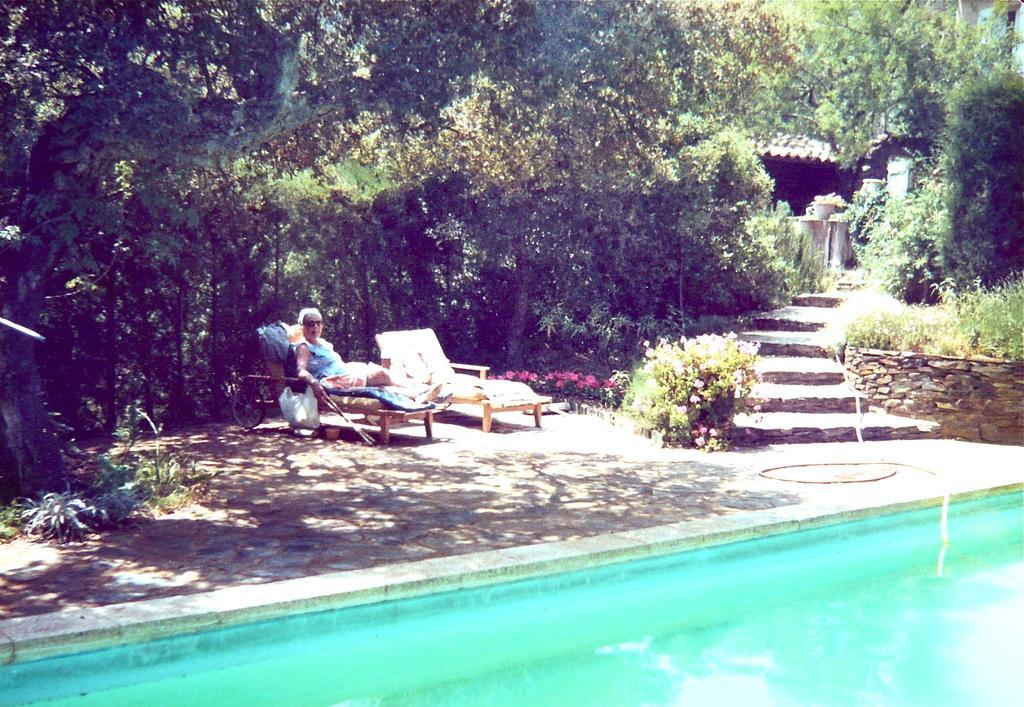Could you give a brief overview of what you see in this image? In this image I can see the water, the ground, a person sitting on a chair, few flowers which are pink in color and few trees which are green in color. I can see few stairs and a building. 